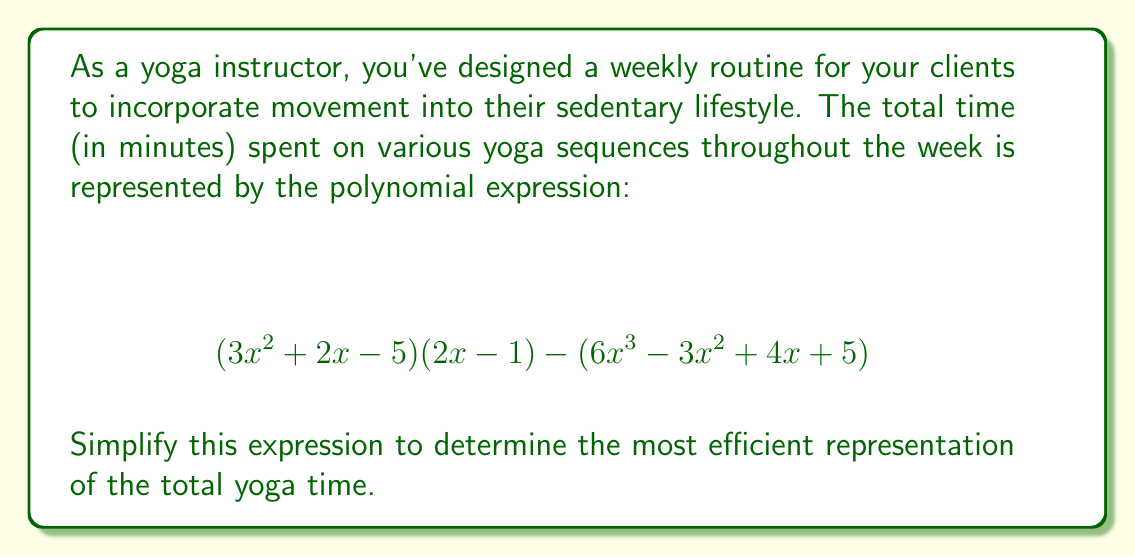What is the answer to this math problem? Let's simplify this polynomial expression step by step:

1) First, let's expand $(3x^2 + 2x - 5)(2x - 1)$:
   $$(3x^2 + 2x - 5)(2x - 1) = 6x^3 + 4x^2 - 10x - 3x^2 - 2x + 5$$
   $$= 6x^3 + x^2 - 12x + 5$$

2) Now our expression looks like:
   $$(6x^3 + x^2 - 12x + 5) - (6x^3 - 3x^2 + 4x + 5)$$

3) Let's subtract the second polynomial from the first:
   
   For $6x^3$: $6x^3 - 6x^3 = 0$
   For $x^2$: $x^2 - (-3x^2) = x^2 + 3x^2 = 4x^2$
   For $x$: $-12x - 4x = -16x$
   For the constant: $5 - 5 = 0$

4) Combining these results, we get:
   $$0 + 4x^2 - 16x + 0 = 4x^2 - 16x$$

This simplified expression represents the most efficient form of the total yoga time polynomial.
Answer: $$4x^2 - 16x$$ 